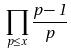<formula> <loc_0><loc_0><loc_500><loc_500>\prod _ { p \leq x } \frac { p - 1 } { p }</formula> 